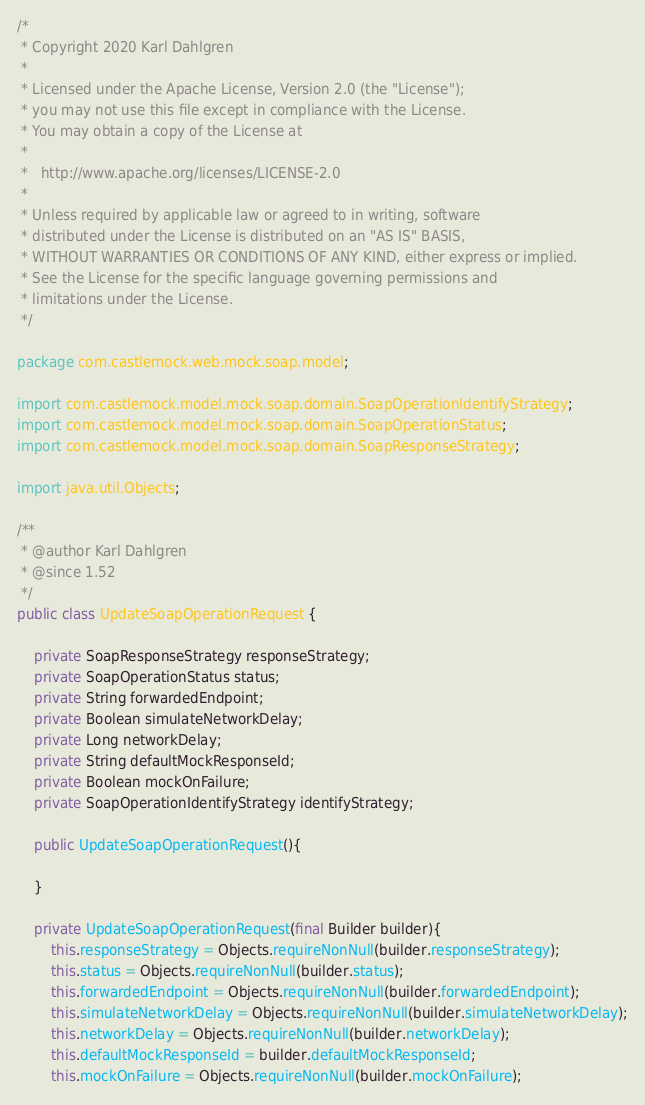Convert code to text. <code><loc_0><loc_0><loc_500><loc_500><_Java_>/*
 * Copyright 2020 Karl Dahlgren
 *
 * Licensed under the Apache License, Version 2.0 (the "License");
 * you may not use this file except in compliance with the License.
 * You may obtain a copy of the License at
 *
 *   http://www.apache.org/licenses/LICENSE-2.0
 *
 * Unless required by applicable law or agreed to in writing, software
 * distributed under the License is distributed on an "AS IS" BASIS,
 * WITHOUT WARRANTIES OR CONDITIONS OF ANY KIND, either express or implied.
 * See the License for the specific language governing permissions and
 * limitations under the License.
 */

package com.castlemock.web.mock.soap.model;

import com.castlemock.model.mock.soap.domain.SoapOperationIdentifyStrategy;
import com.castlemock.model.mock.soap.domain.SoapOperationStatus;
import com.castlemock.model.mock.soap.domain.SoapResponseStrategy;

import java.util.Objects;

/**
 * @author Karl Dahlgren
 * @since 1.52
 */
public class UpdateSoapOperationRequest {

    private SoapResponseStrategy responseStrategy;
    private SoapOperationStatus status;
    private String forwardedEndpoint;
    private Boolean simulateNetworkDelay;
    private Long networkDelay;
    private String defaultMockResponseId;
    private Boolean mockOnFailure;
    private SoapOperationIdentifyStrategy identifyStrategy;

    public UpdateSoapOperationRequest(){

    }

    private UpdateSoapOperationRequest(final Builder builder){
        this.responseStrategy = Objects.requireNonNull(builder.responseStrategy);
        this.status = Objects.requireNonNull(builder.status);
        this.forwardedEndpoint = Objects.requireNonNull(builder.forwardedEndpoint);
        this.simulateNetworkDelay = Objects.requireNonNull(builder.simulateNetworkDelay);
        this.networkDelay = Objects.requireNonNull(builder.networkDelay);
        this.defaultMockResponseId = builder.defaultMockResponseId;
        this.mockOnFailure = Objects.requireNonNull(builder.mockOnFailure);</code> 